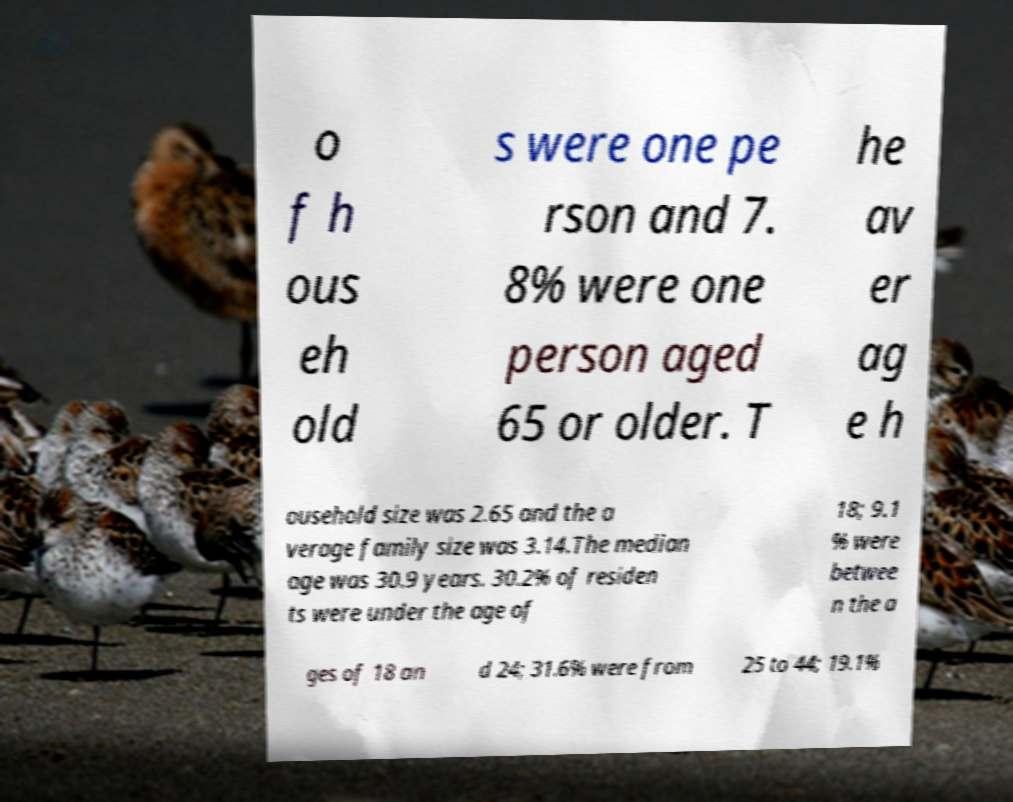Can you read and provide the text displayed in the image?This photo seems to have some interesting text. Can you extract and type it out for me? o f h ous eh old s were one pe rson and 7. 8% were one person aged 65 or older. T he av er ag e h ousehold size was 2.65 and the a verage family size was 3.14.The median age was 30.9 years. 30.2% of residen ts were under the age of 18; 9.1 % were betwee n the a ges of 18 an d 24; 31.6% were from 25 to 44; 19.1% 